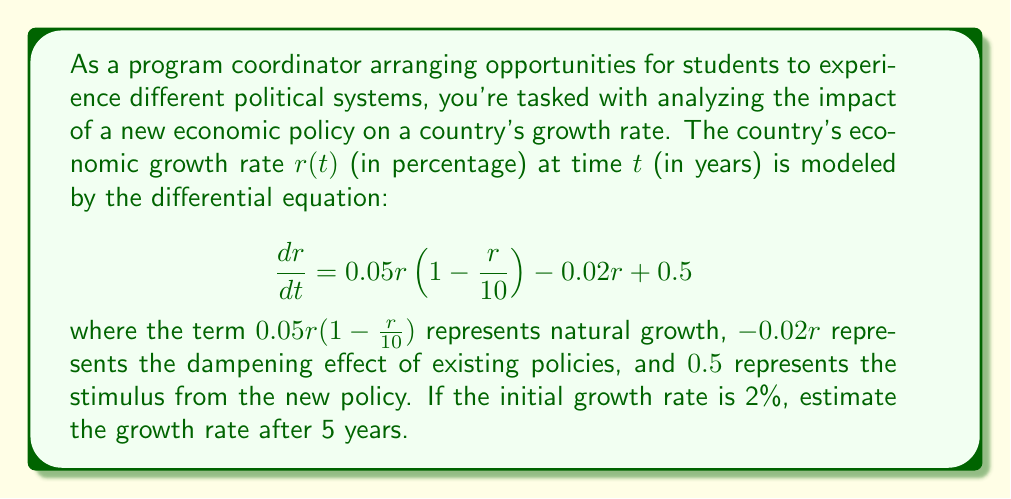Give your solution to this math problem. To solve this problem, we need to use numerical methods to approximate the solution of the differential equation. We'll use the fourth-order Runge-Kutta method (RK4) for better accuracy.

Given:
- Initial condition: $r(0) = 2$
- Time interval: $t = 0$ to $t = 5$
- Differential equation: $\frac{dr}{dt} = 0.05r(1 - \frac{r}{10}) - 0.02r + 0.5$

Let's define $f(t, r) = 0.05r(1 - \frac{r}{10}) - 0.02r + 0.5$

We'll use a step size of $h = 0.5$ years, which means we'll have 10 steps.

RK4 method:
For each step, calculate:
$k_1 = hf(t_n, r_n)$
$k_2 = hf(t_n + \frac{h}{2}, r_n + \frac{k_1}{2})$
$k_3 = hf(t_n + \frac{h}{2}, r_n + \frac{k_2}{2})$
$k_4 = hf(t_n + h, r_n + k_3)$

Then update: $r_{n+1} = r_n + \frac{1}{6}(k_1 + 2k_2 + 2k_3 + k_4)$

Step 1 (t = 0 to 0.5):
$k_1 = 0.5 \cdot f(0, 2) = 0.5 \cdot (0.05 \cdot 2 \cdot (1 - \frac{2}{10}) - 0.02 \cdot 2 + 0.5) = 0.49$
$k_2 = 0.5 \cdot f(0.25, 2.245) = 0.5265$
$k_3 = 0.5 \cdot f(0.25, 2.2633) = 0.5291$
$k_4 = 0.5 \cdot f(0.5, 2.5291) = 0.5639$

$r_1 = 2 + \frac{1}{6}(0.49 + 2 \cdot 0.5265 + 2 \cdot 0.5291 + 0.5639) = 2.5291$

Continuing this process for the remaining steps:

Step 2 (t = 0.5 to 1): $r_2 = 3.0859$
Step 3 (t = 1 to 1.5): $r_3 = 3.6553$
Step 4 (t = 1.5 to 2): $r_4 = 4.2207$
Step 5 (t = 2 to 2.5): $r_5 = 4.7664$
Step 6 (t = 2.5 to 3): $r_6 = 5.2785$
Step 7 (t = 3 to 3.5): $r_7 = 5.7460$
Step 8 (t = 3.5 to 4): $r_8 = 6.1611$
Step 9 (t = 4 to 4.5): $r_9 = 6.5188$
Step 10 (t = 4.5 to 5): $r_{10} = 6.8173$

Therefore, after 5 years, the estimated growth rate is approximately 6.8173%.
Answer: 6.82% 